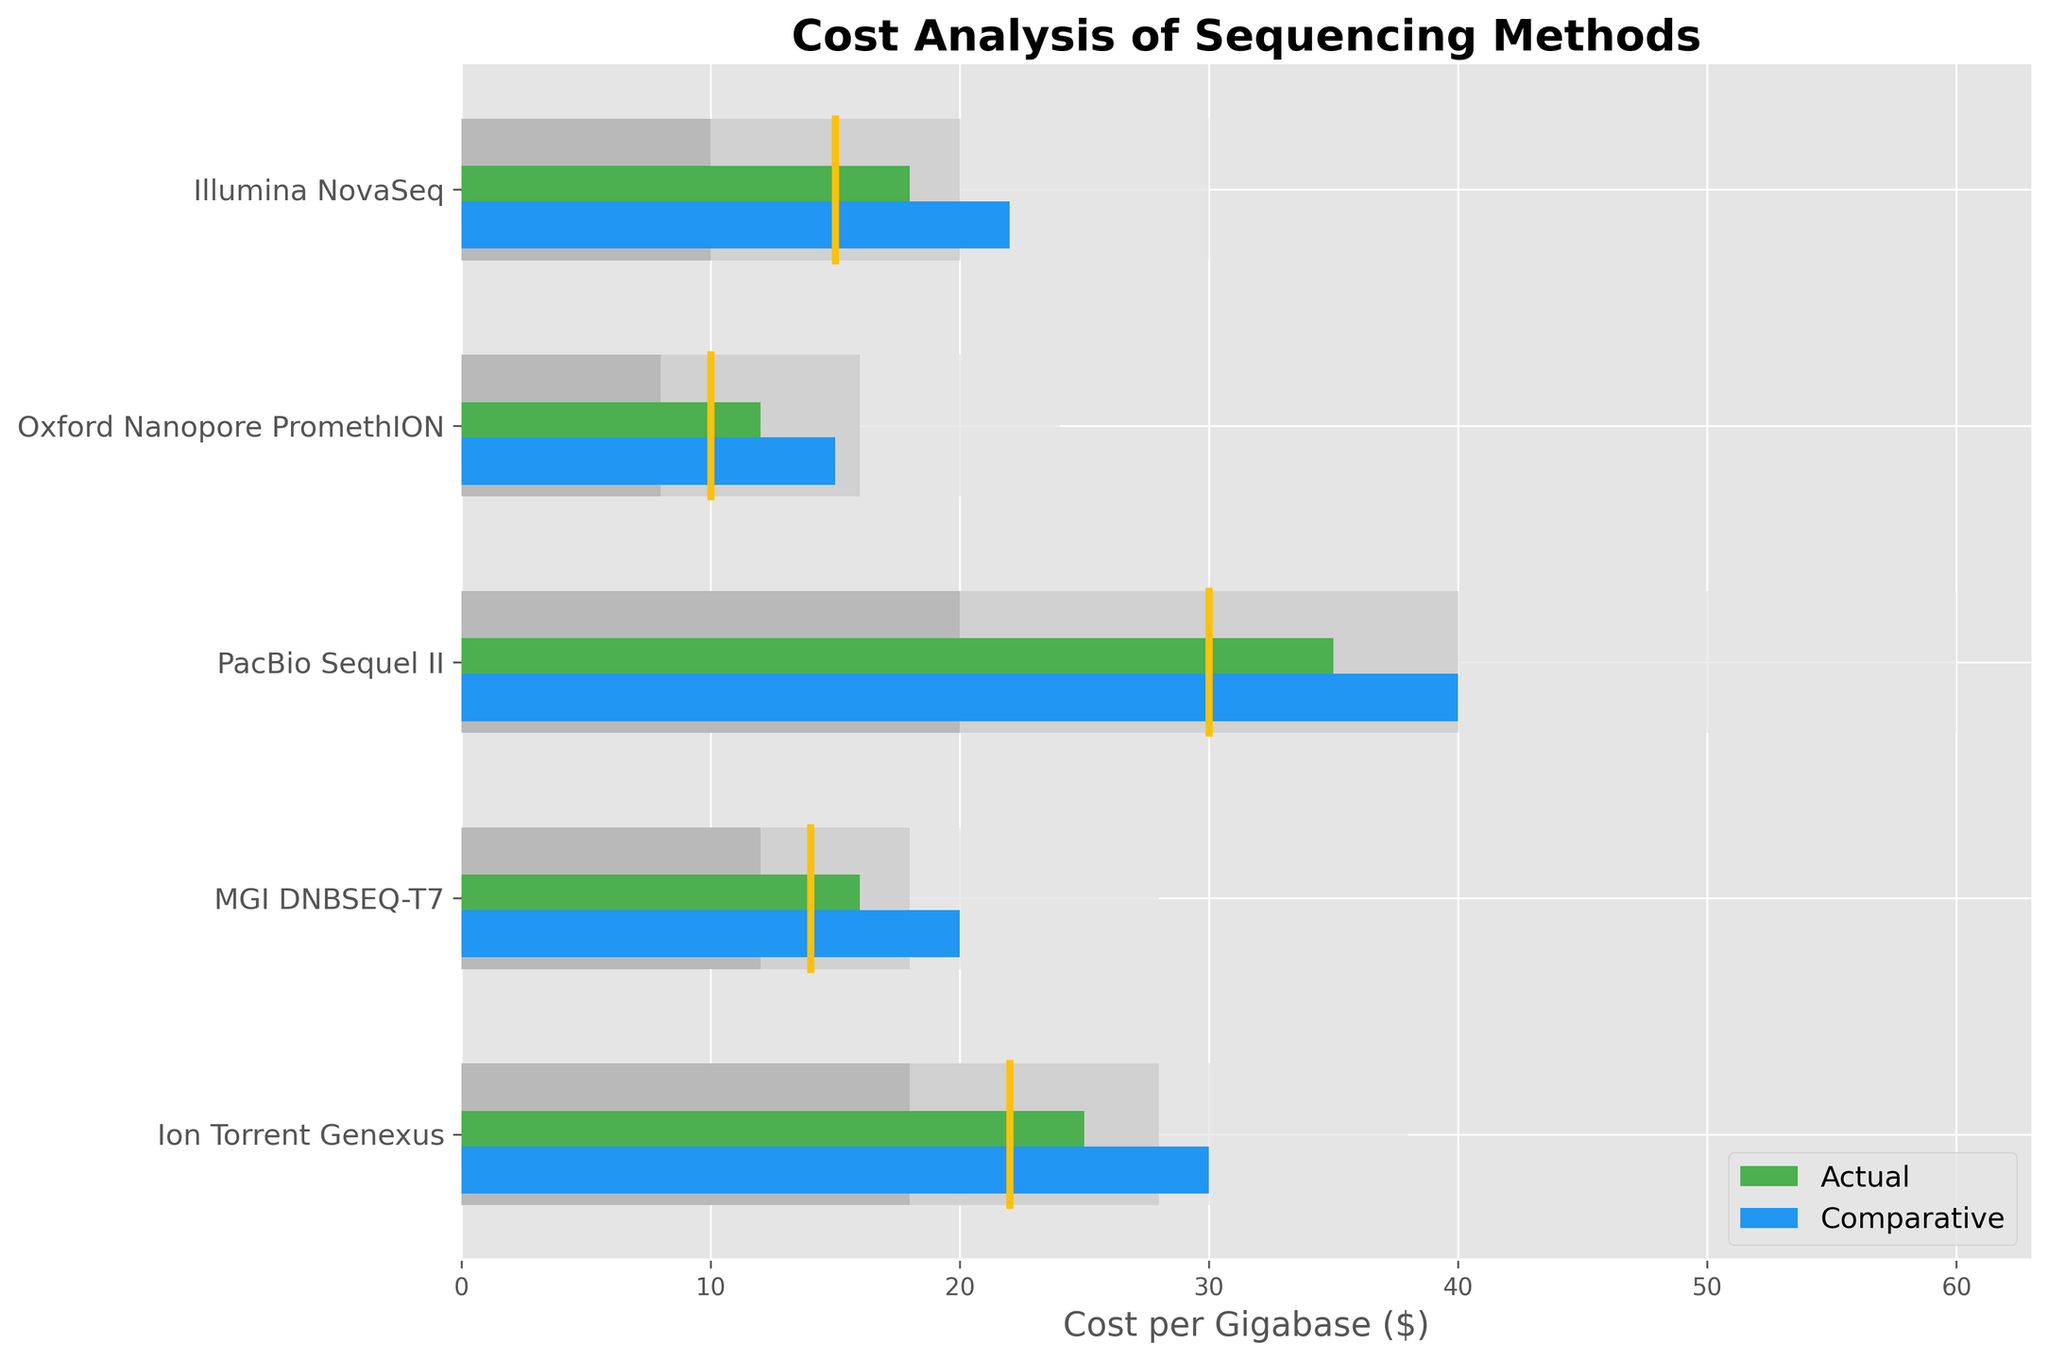What is the title of the chart? The title of the chart is found at the top center of the figure. It reads "Cost Analysis of Sequencing Methods."
Answer: Cost Analysis of Sequencing Methods What does the x-axis in the chart represent? The x-axis label is found at the bottom of the chart. It specifies that the x-axis represents "Cost per Gigabase ($)."
Answer: Cost per Gigabase ($) How many categories of sequencing methods are compared in the chart? By counting the unique items listed on the y-axis, we see there are five categories of sequencing methods displayed.
Answer: 5 Which sequencing method shows the highest actual cost per gigabase? By examining the green bars representing actual costs, the "PacBio Sequel II" has the longest green bar, indicating the highest actual cost.
Answer: PacBio Sequel II What is the target cost for the "Ion Torrent Genexus"? The target cost is indicated by vertical yellow lines. For "Ion Torrent Genexus," this line intersects at 22 on the x-axis.
Answer: 22 Which sequencing method's actual cost is closest to its target cost? By comparing the lengths of green bars to the yellow target lines, "Illumina NovaSeq" appears closest to its target value of 15, with an actual cost of 18.
Answer: Illumina NovaSeq How does the actual cost of "MGI DNBSEQ-T7" compare to its comparative cost? The green bar representing actual cost is shorter than the blue bar representing the comparative value for "MGI DNBSEQ-T7." The actual cost is 16, and the comparative cost is 20.
Answer: The actual cost is lower than the comparative cost Among the categories presented, which one has the highest target cost? By identifying the highest value among yellow lines, "PacBio Sequel II" has the highest target cost at 30.
Answer: PacBio Sequel II What is the difference between the actual and target costs for "Oxford Nanopore PromethION"? The actual cost is represented by the green bar at 12, while the target cost is marked by the yellow line at 10. The difference is 12 - 10 = 2.
Answer: 2 Which sequencing method's actual cost is within the "Range 1"? Range 1 is represented by the darkest gray bars. "Illumina NovaSeq" and "Oxford Nanopore PromethION" have actual costs of 18 and 12, both within their respective Range 1 values of 10.
Answer: Illumina NovaSeq, Oxford Nanopore PromethION 